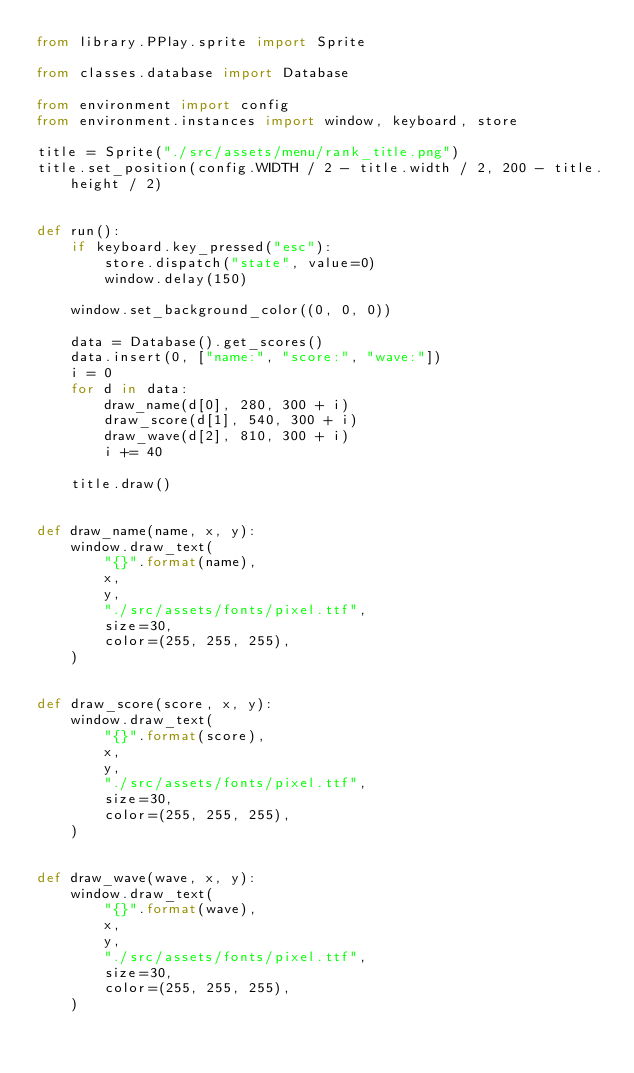Convert code to text. <code><loc_0><loc_0><loc_500><loc_500><_Python_>from library.PPlay.sprite import Sprite

from classes.database import Database

from environment import config
from environment.instances import window, keyboard, store

title = Sprite("./src/assets/menu/rank_title.png")
title.set_position(config.WIDTH / 2 - title.width / 2, 200 - title.height / 2)


def run():
    if keyboard.key_pressed("esc"):
        store.dispatch("state", value=0)
        window.delay(150)

    window.set_background_color((0, 0, 0))

    data = Database().get_scores()
    data.insert(0, ["name:", "score:", "wave:"])
    i = 0
    for d in data:
        draw_name(d[0], 280, 300 + i)
        draw_score(d[1], 540, 300 + i)
        draw_wave(d[2], 810, 300 + i)
        i += 40

    title.draw()


def draw_name(name, x, y):
    window.draw_text(
        "{}".format(name),
        x,
        y,
        "./src/assets/fonts/pixel.ttf",
        size=30,
        color=(255, 255, 255),
    )


def draw_score(score, x, y):
    window.draw_text(
        "{}".format(score),
        x,
        y,
        "./src/assets/fonts/pixel.ttf",
        size=30,
        color=(255, 255, 255),
    )


def draw_wave(wave, x, y):
    window.draw_text(
        "{}".format(wave),
        x,
        y,
        "./src/assets/fonts/pixel.ttf",
        size=30,
        color=(255, 255, 255),
    )
</code> 